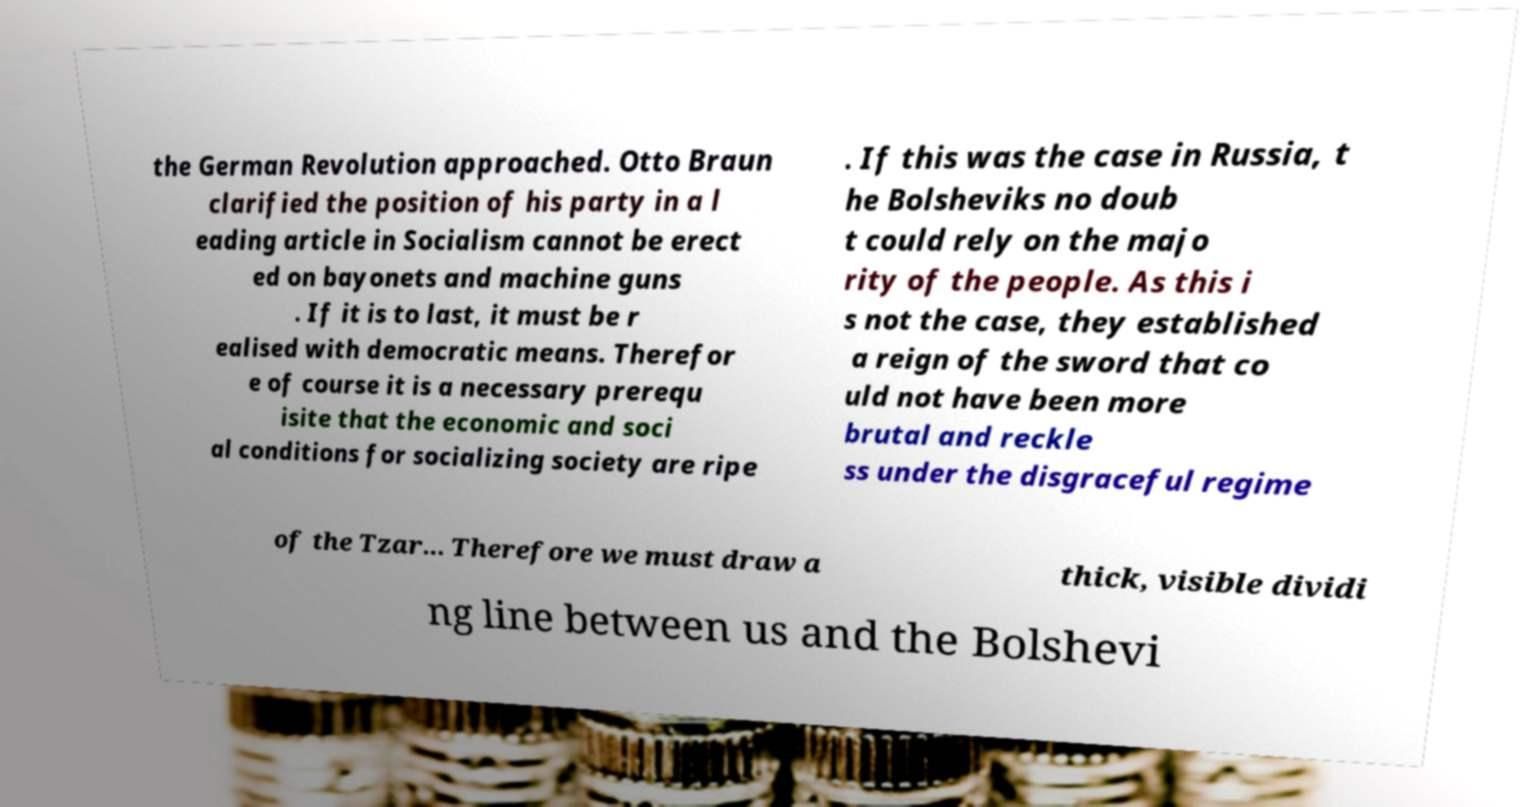What messages or text are displayed in this image? I need them in a readable, typed format. the German Revolution approached. Otto Braun clarified the position of his party in a l eading article in Socialism cannot be erect ed on bayonets and machine guns . If it is to last, it must be r ealised with democratic means. Therefor e of course it is a necessary prerequ isite that the economic and soci al conditions for socializing society are ripe . If this was the case in Russia, t he Bolsheviks no doub t could rely on the majo rity of the people. As this i s not the case, they established a reign of the sword that co uld not have been more brutal and reckle ss under the disgraceful regime of the Tzar... Therefore we must draw a thick, visible dividi ng line between us and the Bolshevi 